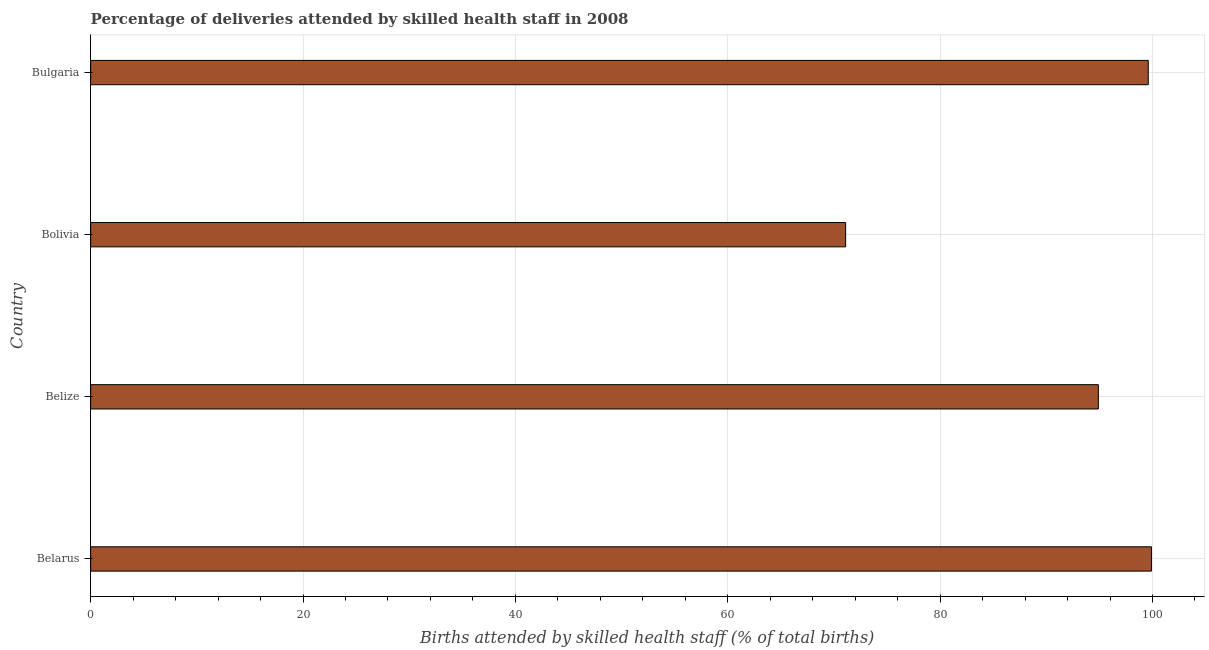Does the graph contain any zero values?
Ensure brevity in your answer.  No. What is the title of the graph?
Keep it short and to the point. Percentage of deliveries attended by skilled health staff in 2008. What is the label or title of the X-axis?
Keep it short and to the point. Births attended by skilled health staff (% of total births). What is the label or title of the Y-axis?
Keep it short and to the point. Country. What is the number of births attended by skilled health staff in Belize?
Provide a short and direct response. 94.9. Across all countries, what is the maximum number of births attended by skilled health staff?
Ensure brevity in your answer.  99.9. Across all countries, what is the minimum number of births attended by skilled health staff?
Your response must be concise. 71.1. In which country was the number of births attended by skilled health staff maximum?
Offer a very short reply. Belarus. In which country was the number of births attended by skilled health staff minimum?
Your answer should be compact. Bolivia. What is the sum of the number of births attended by skilled health staff?
Provide a succinct answer. 365.5. What is the difference between the number of births attended by skilled health staff in Bolivia and Bulgaria?
Your answer should be compact. -28.5. What is the average number of births attended by skilled health staff per country?
Your answer should be very brief. 91.38. What is the median number of births attended by skilled health staff?
Offer a terse response. 97.25. What is the ratio of the number of births attended by skilled health staff in Belarus to that in Bulgaria?
Offer a very short reply. 1. Is the sum of the number of births attended by skilled health staff in Belize and Bolivia greater than the maximum number of births attended by skilled health staff across all countries?
Your answer should be very brief. Yes. What is the difference between the highest and the lowest number of births attended by skilled health staff?
Ensure brevity in your answer.  28.8. In how many countries, is the number of births attended by skilled health staff greater than the average number of births attended by skilled health staff taken over all countries?
Your answer should be compact. 3. Are all the bars in the graph horizontal?
Offer a very short reply. Yes. What is the difference between two consecutive major ticks on the X-axis?
Your response must be concise. 20. What is the Births attended by skilled health staff (% of total births) in Belarus?
Your answer should be very brief. 99.9. What is the Births attended by skilled health staff (% of total births) in Belize?
Provide a succinct answer. 94.9. What is the Births attended by skilled health staff (% of total births) in Bolivia?
Your answer should be compact. 71.1. What is the Births attended by skilled health staff (% of total births) of Bulgaria?
Your answer should be very brief. 99.6. What is the difference between the Births attended by skilled health staff (% of total births) in Belarus and Bolivia?
Ensure brevity in your answer.  28.8. What is the difference between the Births attended by skilled health staff (% of total births) in Belize and Bolivia?
Offer a very short reply. 23.8. What is the difference between the Births attended by skilled health staff (% of total births) in Belize and Bulgaria?
Give a very brief answer. -4.7. What is the difference between the Births attended by skilled health staff (% of total births) in Bolivia and Bulgaria?
Offer a very short reply. -28.5. What is the ratio of the Births attended by skilled health staff (% of total births) in Belarus to that in Belize?
Give a very brief answer. 1.05. What is the ratio of the Births attended by skilled health staff (% of total births) in Belarus to that in Bolivia?
Keep it short and to the point. 1.41. What is the ratio of the Births attended by skilled health staff (% of total births) in Belarus to that in Bulgaria?
Offer a terse response. 1. What is the ratio of the Births attended by skilled health staff (% of total births) in Belize to that in Bolivia?
Make the answer very short. 1.33. What is the ratio of the Births attended by skilled health staff (% of total births) in Belize to that in Bulgaria?
Your answer should be very brief. 0.95. What is the ratio of the Births attended by skilled health staff (% of total births) in Bolivia to that in Bulgaria?
Keep it short and to the point. 0.71. 